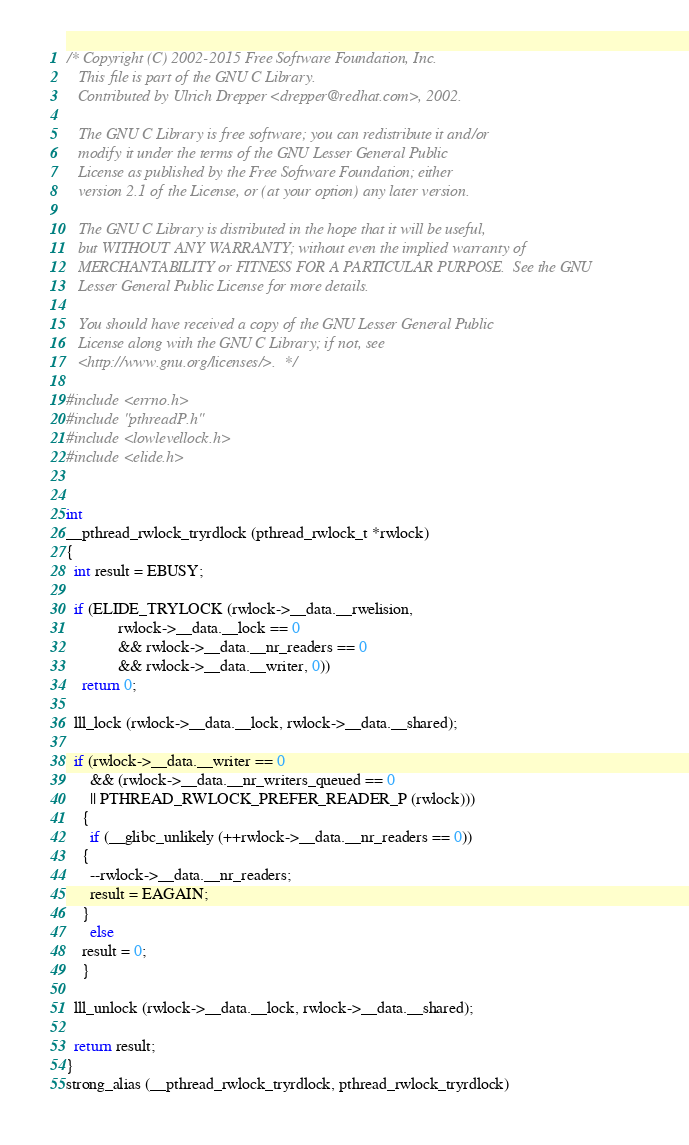<code> <loc_0><loc_0><loc_500><loc_500><_C_>/* Copyright (C) 2002-2015 Free Software Foundation, Inc.
   This file is part of the GNU C Library.
   Contributed by Ulrich Drepper <drepper@redhat.com>, 2002.

   The GNU C Library is free software; you can redistribute it and/or
   modify it under the terms of the GNU Lesser General Public
   License as published by the Free Software Foundation; either
   version 2.1 of the License, or (at your option) any later version.

   The GNU C Library is distributed in the hope that it will be useful,
   but WITHOUT ANY WARRANTY; without even the implied warranty of
   MERCHANTABILITY or FITNESS FOR A PARTICULAR PURPOSE.  See the GNU
   Lesser General Public License for more details.

   You should have received a copy of the GNU Lesser General Public
   License along with the GNU C Library; if not, see
   <http://www.gnu.org/licenses/>.  */

#include <errno.h>
#include "pthreadP.h"
#include <lowlevellock.h>
#include <elide.h>


int
__pthread_rwlock_tryrdlock (pthread_rwlock_t *rwlock)
{
  int result = EBUSY;

  if (ELIDE_TRYLOCK (rwlock->__data.__rwelision,
		     rwlock->__data.__lock == 0
		     && rwlock->__data.__nr_readers == 0
		     && rwlock->__data.__writer, 0))
    return 0;

  lll_lock (rwlock->__data.__lock, rwlock->__data.__shared);

  if (rwlock->__data.__writer == 0
      && (rwlock->__data.__nr_writers_queued == 0
	  || PTHREAD_RWLOCK_PREFER_READER_P (rwlock)))
    {
      if (__glibc_unlikely (++rwlock->__data.__nr_readers == 0))
	{
	  --rwlock->__data.__nr_readers;
	  result = EAGAIN;
	}
      else
	result = 0;
    }

  lll_unlock (rwlock->__data.__lock, rwlock->__data.__shared);

  return result;
}
strong_alias (__pthread_rwlock_tryrdlock, pthread_rwlock_tryrdlock)
</code> 